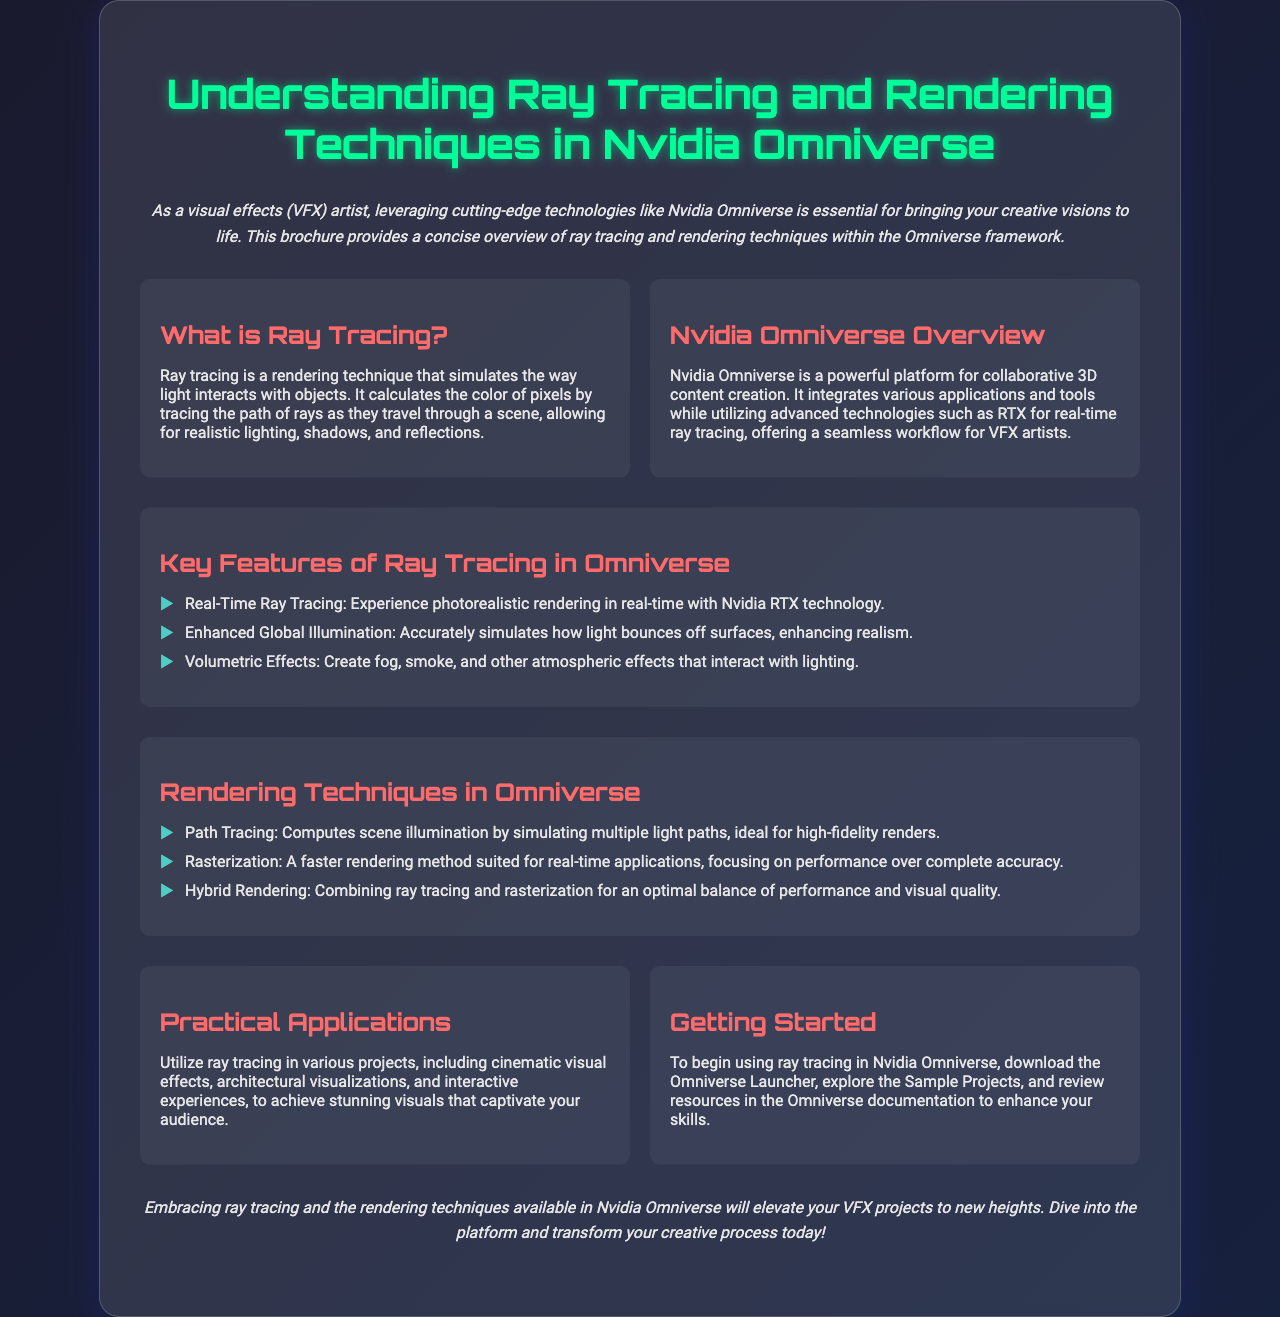What is ray tracing? Ray tracing is defined in the document as a rendering technique that simulates the way light interacts with objects by calculating pixel colors through the path of rays in a scene.
Answer: A rendering technique What technology does Nvidia Omniverse utilize for real-time ray tracing? The document mentions Nvidia RTX technology as providing the capability for real-time ray tracing within the Omniverse.
Answer: Nvidia RTX technology What are the three key features of ray tracing in Omniverse? The document lists three key features: Real-Time Ray Tracing, Enhanced Global Illumination, and Volumetric Effects.
Answer: Real-Time Ray Tracing, Enhanced Global Illumination, Volumetric Effects What is the primary focus of rasterization as a rendering technique? The document describes rasterization as focusing on performance over complete accuracy, indicating its primary focus.
Answer: Performance How many practical applications of ray tracing are mentioned? The document references practical applications for various projects, but does not specify an exact number, only cites types such as cinematic visual effects and architectural visualizations.
Answer: Multiple projects What combination of techniques is referred to as hybrid rendering? The document defines hybrid rendering as the combination of ray tracing and rasterization, which is a specific technique mentioned.
Answer: Ray tracing and rasterization Which section discusses getting started with ray tracing? The section titled "Getting Started" specifically covers how to begin using ray tracing in Nvidia Omniverse.
Answer: Getting Started What is emphasized as a benefit of embracing ray tracing in the conclusion? The conclusion highlights that embracing ray tracing will elevate VFX projects to new heights, suggesting significant improvement in quality.
Answer: Elevate your VFX projects to new heights 